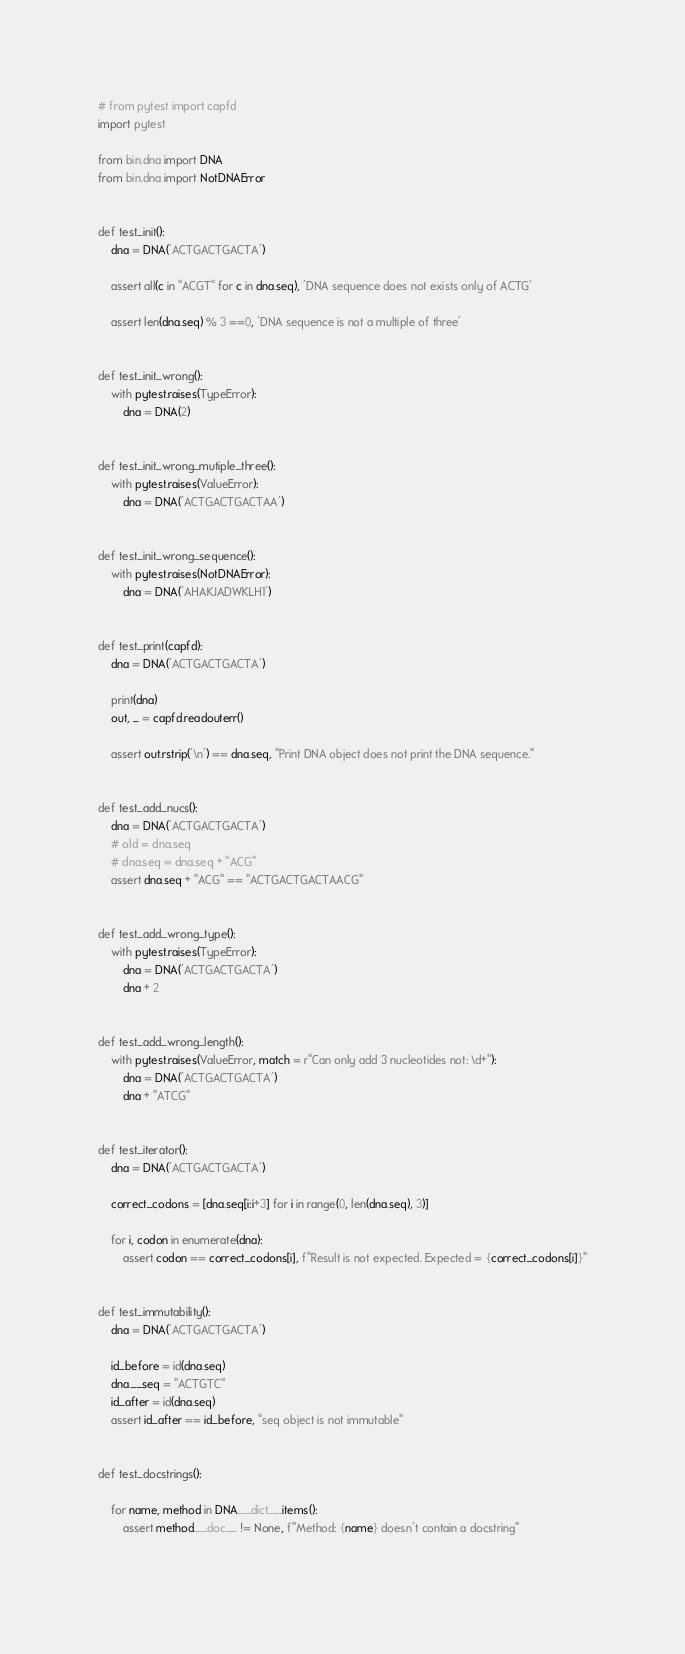<code> <loc_0><loc_0><loc_500><loc_500><_Python_># from pytest import capfd
import pytest

from bin.dna import DNA
from bin.dna import NotDNAError


def test_init():
    dna = DNA('ACTGACTGACTA')

    assert all(c in "ACGT" for c in dna.seq), 'DNA sequence does not exists only of ACTG'

    assert len(dna.seq) % 3 ==0, 'DNA sequence is not a multiple of three'


def test_init_wrong():
    with pytest.raises(TypeError):
        dna = DNA(2)


def test_init_wrong_mutiple_three():
    with pytest.raises(ValueError):
        dna = DNA('ACTGACTGACTAA')


def test_init_wrong_sequence():
    with pytest.raises(NotDNAError):
        dna = DNA('AHAKJADWKLH1')


def test_print(capfd):
    dna = DNA('ACTGACTGACTA')

    print(dna)
    out, _ = capfd.readouterr()

    assert out.rstrip('\n') == dna.seq, "Print DNA object does not print the DNA sequence."


def test_add_nucs():
    dna = DNA('ACTGACTGACTA')
    # old = dna.seq
    # dna.seq = dna.seq + "ACG"
    assert dna.seq + "ACG" == "ACTGACTGACTAACG"


def test_add_wrong_type():
    with pytest.raises(TypeError):
        dna = DNA('ACTGACTGACTA')
        dna + 2


def test_add_wrong_length():
    with pytest.raises(ValueError, match = r"Can only add 3 nucleotides not: \d+"):
        dna = DNA('ACTGACTGACTA')
        dna + "ATCG"


def test_iterator():
    dna = DNA('ACTGACTGACTA')

    correct_codons = [dna.seq[i:i+3] for i in range(0, len(dna.seq), 3)]

    for i, codon in enumerate(dna):
        assert codon == correct_codons[i], f"Result is not expected. Expected = {correct_codons[i]}"
    

def test_immutability():
    dna = DNA('ACTGACTGACTA')

    id_before = id(dna.seq)
    dna.__seq = "ACTGTC"
    id_after = id(dna.seq)
    assert id_after == id_before, "seq object is not immutable"


def test_docstrings():

    for name, method in DNA.__dict__.items():
        assert method.__doc__ != None, f"Method: {name} doesn't contain a docstring"
            

</code> 